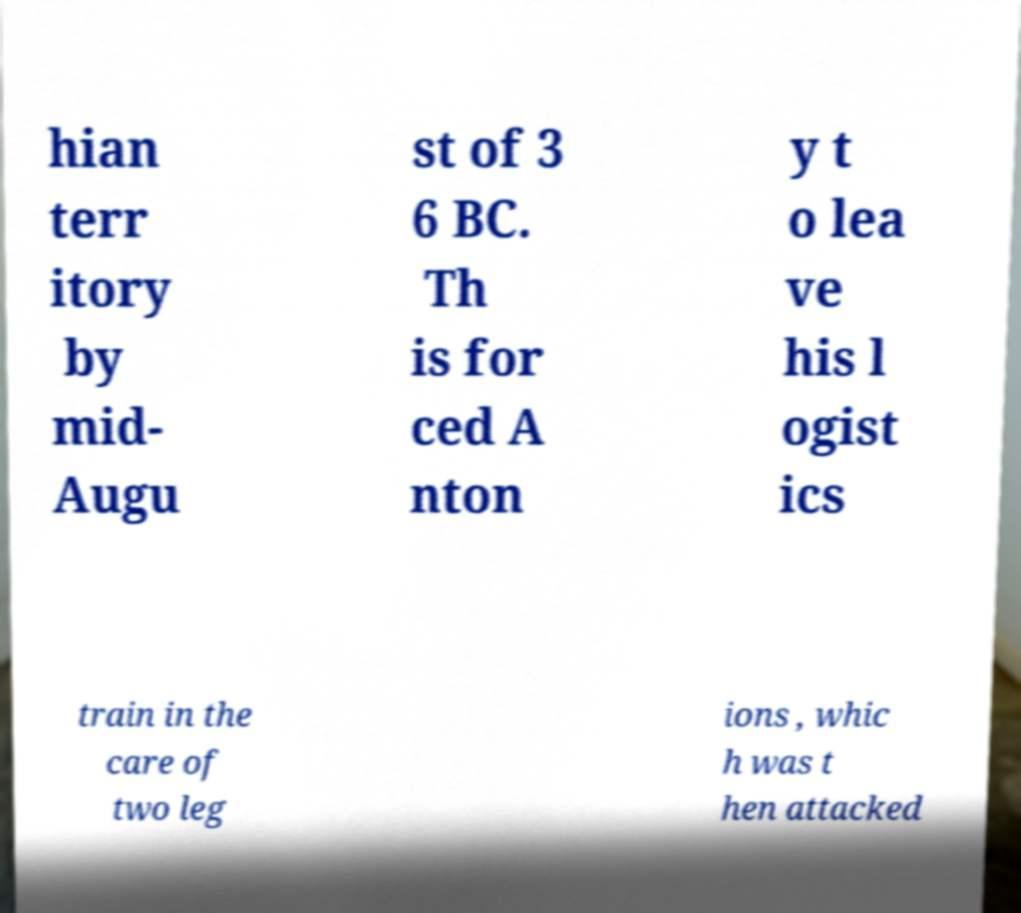There's text embedded in this image that I need extracted. Can you transcribe it verbatim? hian terr itory by mid- Augu st of 3 6 BC. Th is for ced A nton y t o lea ve his l ogist ics train in the care of two leg ions , whic h was t hen attacked 